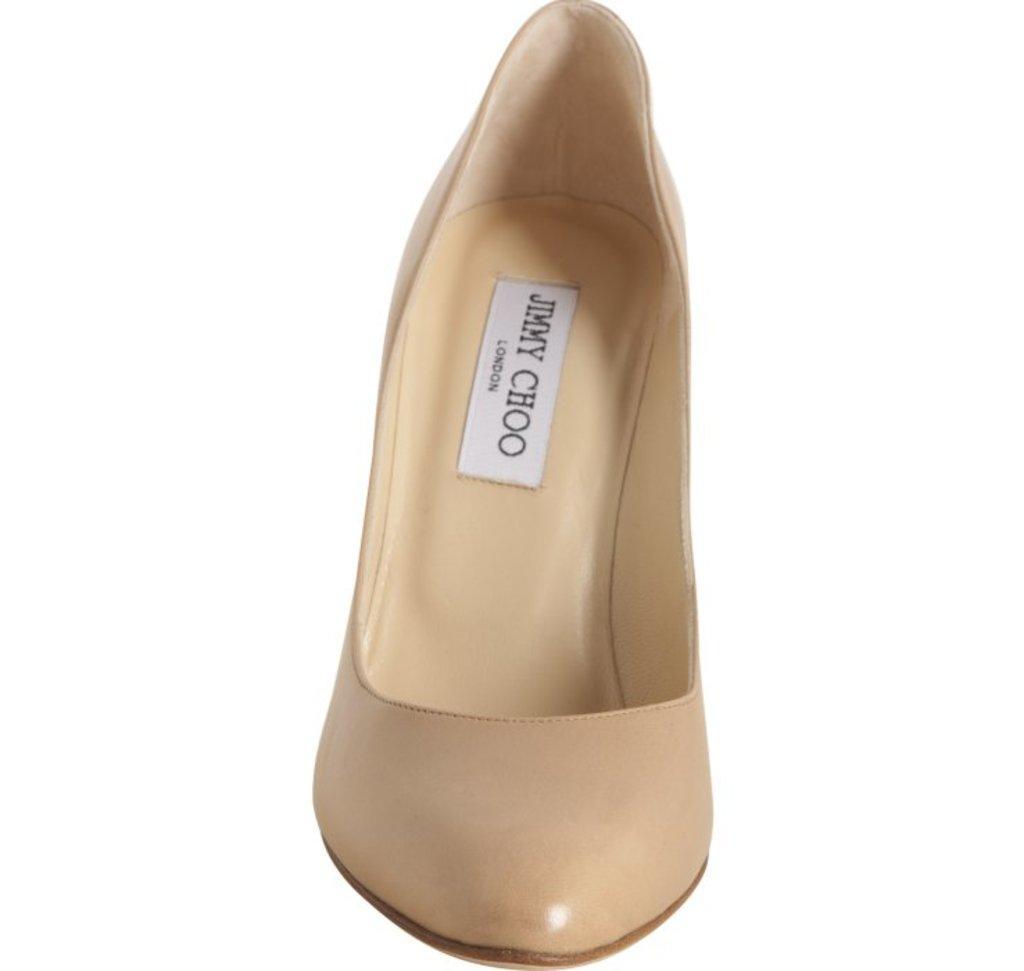How would you summarize this image in a sentence or two? It is the image of a women footwear. 